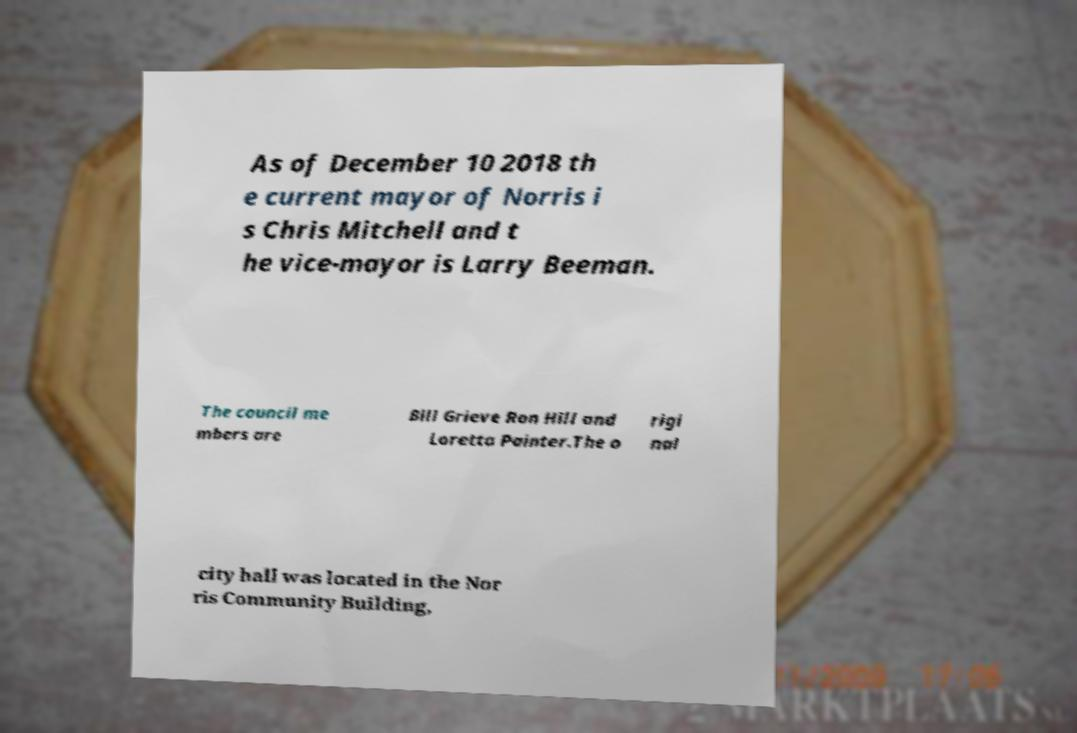I need the written content from this picture converted into text. Can you do that? As of December 10 2018 th e current mayor of Norris i s Chris Mitchell and t he vice-mayor is Larry Beeman. The council me mbers are Bill Grieve Ron Hill and Loretta Painter.The o rigi nal city hall was located in the Nor ris Community Building, 